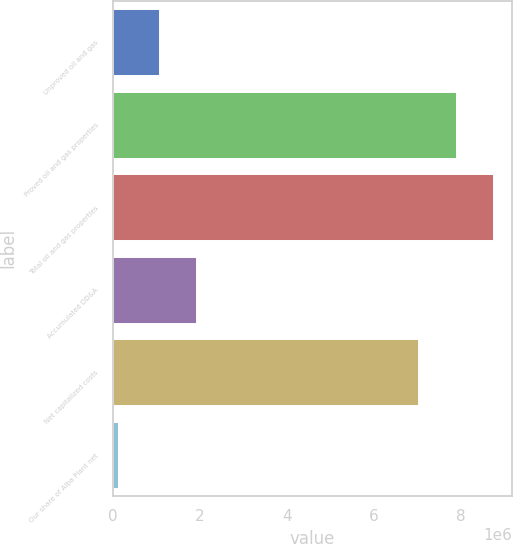Convert chart. <chart><loc_0><loc_0><loc_500><loc_500><bar_chart><fcel>Unproved oil and gas<fcel>Proved oil and gas properties<fcel>Total oil and gas properties<fcel>Accumulated DD&A<fcel>Net capitalized costs<fcel>Our share of Alba Plant net<nl><fcel>1.05325e+06<fcel>7.87723e+06<fcel>8.73729e+06<fcel>1.91331e+06<fcel>7.01716e+06<fcel>124454<nl></chart> 